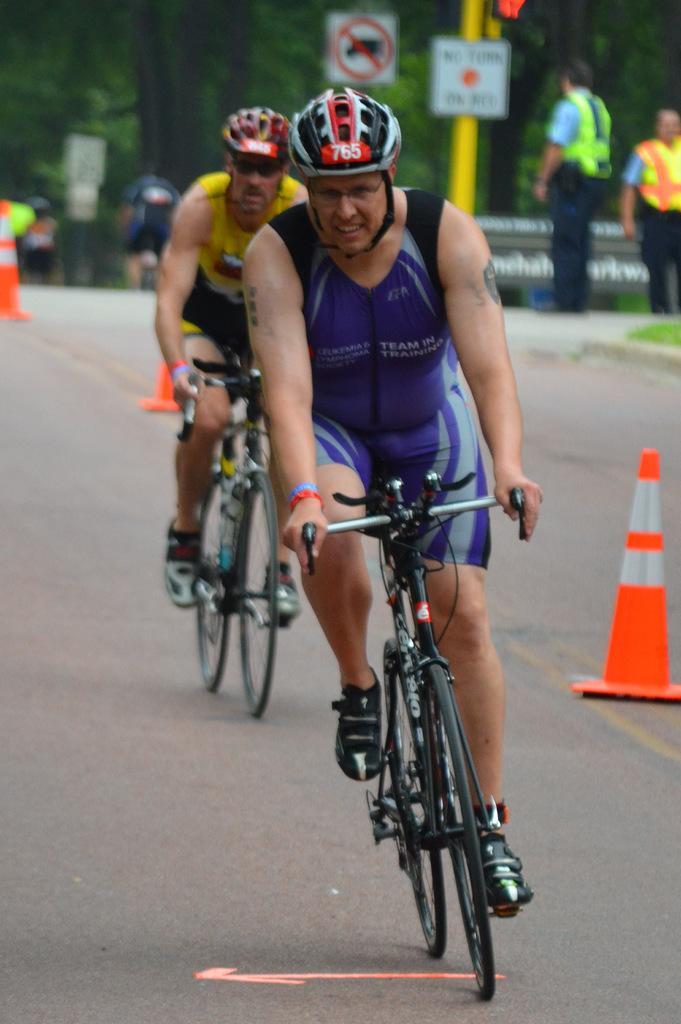Could you give a brief overview of what you see in this image? As we can see in the image there are trees and two people riding bicycles. 